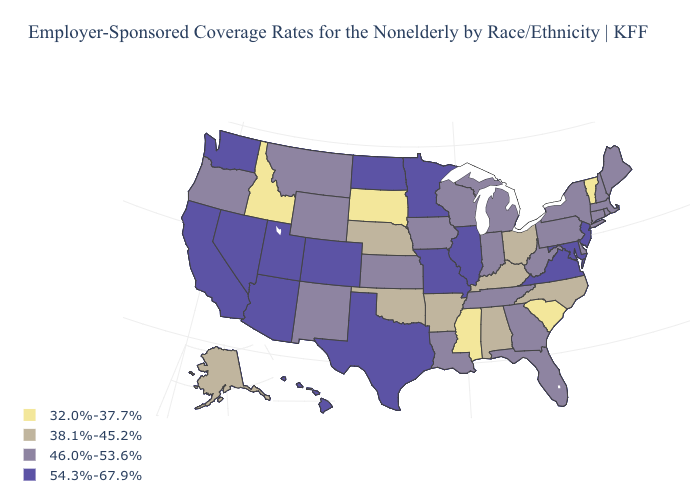What is the value of Arizona?
Quick response, please. 54.3%-67.9%. What is the value of Oklahoma?
Quick response, please. 38.1%-45.2%. What is the value of Colorado?
Concise answer only. 54.3%-67.9%. Name the states that have a value in the range 32.0%-37.7%?
Concise answer only. Idaho, Mississippi, South Carolina, South Dakota, Vermont. What is the value of Georgia?
Give a very brief answer. 46.0%-53.6%. Does the map have missing data?
Quick response, please. No. What is the lowest value in states that border Arizona?
Answer briefly. 46.0%-53.6%. Which states have the lowest value in the USA?
Short answer required. Idaho, Mississippi, South Carolina, South Dakota, Vermont. Name the states that have a value in the range 54.3%-67.9%?
Keep it brief. Arizona, California, Colorado, Hawaii, Illinois, Maryland, Minnesota, Missouri, Nevada, New Jersey, North Dakota, Texas, Utah, Virginia, Washington. Does Kentucky have the lowest value in the USA?
Give a very brief answer. No. What is the value of Minnesota?
Quick response, please. 54.3%-67.9%. Name the states that have a value in the range 32.0%-37.7%?
Answer briefly. Idaho, Mississippi, South Carolina, South Dakota, Vermont. What is the lowest value in states that border North Dakota?
Answer briefly. 32.0%-37.7%. What is the highest value in the South ?
Give a very brief answer. 54.3%-67.9%. Which states hav the highest value in the West?
Be succinct. Arizona, California, Colorado, Hawaii, Nevada, Utah, Washington. 